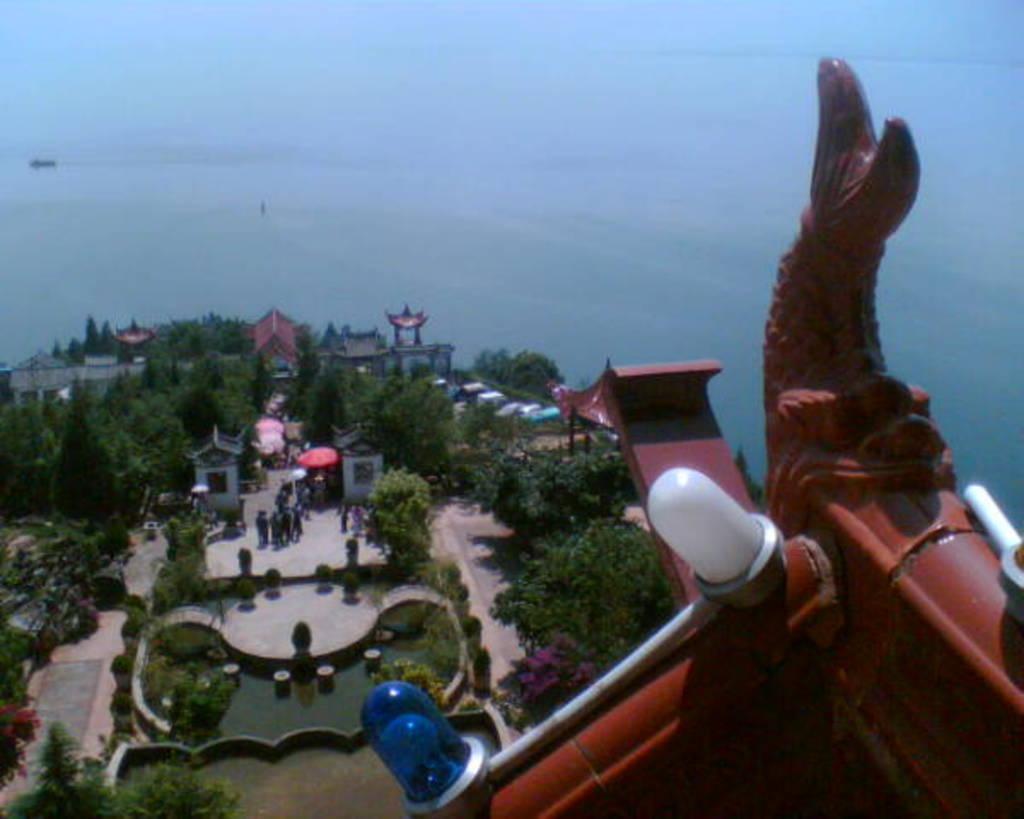Can you describe this image briefly? In this image we can see few trees, buildings, few people standing on the ground and a red color object with lights and the sky in the background. 